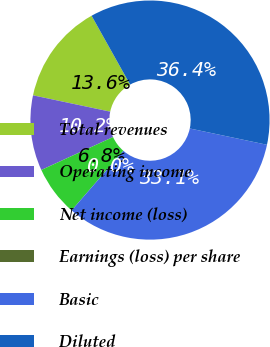Convert chart. <chart><loc_0><loc_0><loc_500><loc_500><pie_chart><fcel>Total revenues<fcel>Operating income<fcel>Net income (loss)<fcel>Earnings (loss) per share<fcel>Basic<fcel>Diluted<nl><fcel>13.56%<fcel>10.17%<fcel>6.78%<fcel>0.0%<fcel>33.06%<fcel>36.44%<nl></chart> 